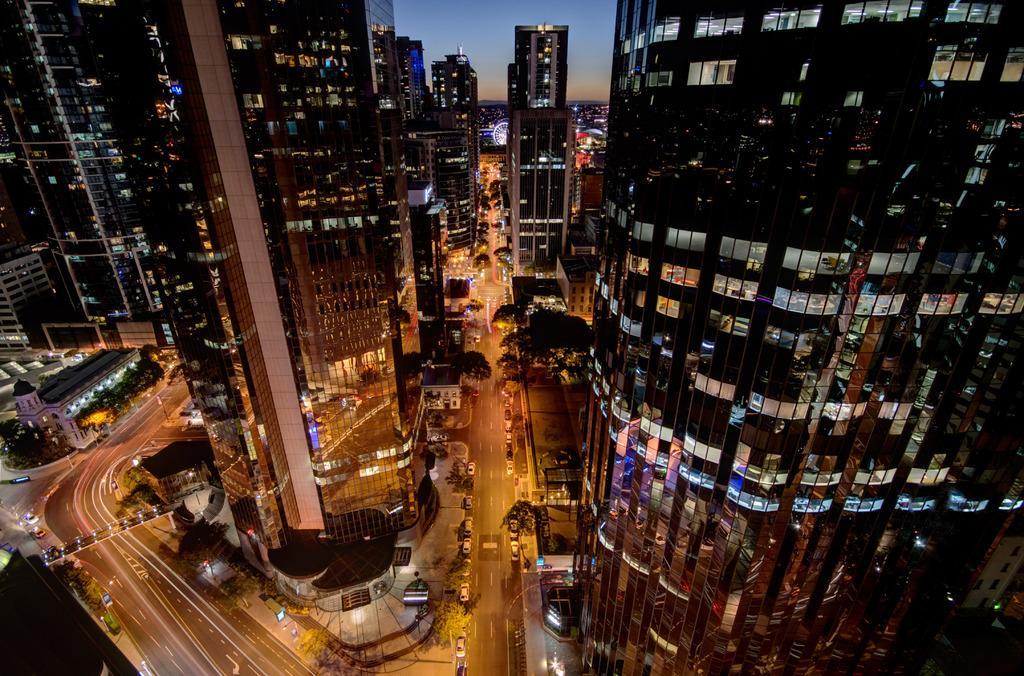Could you give a brief overview of what you see in this image? This image is taken during the night time. In this image we can see the buildings, trees, bridge and also the vehicles on the road. We can also see the sky. 